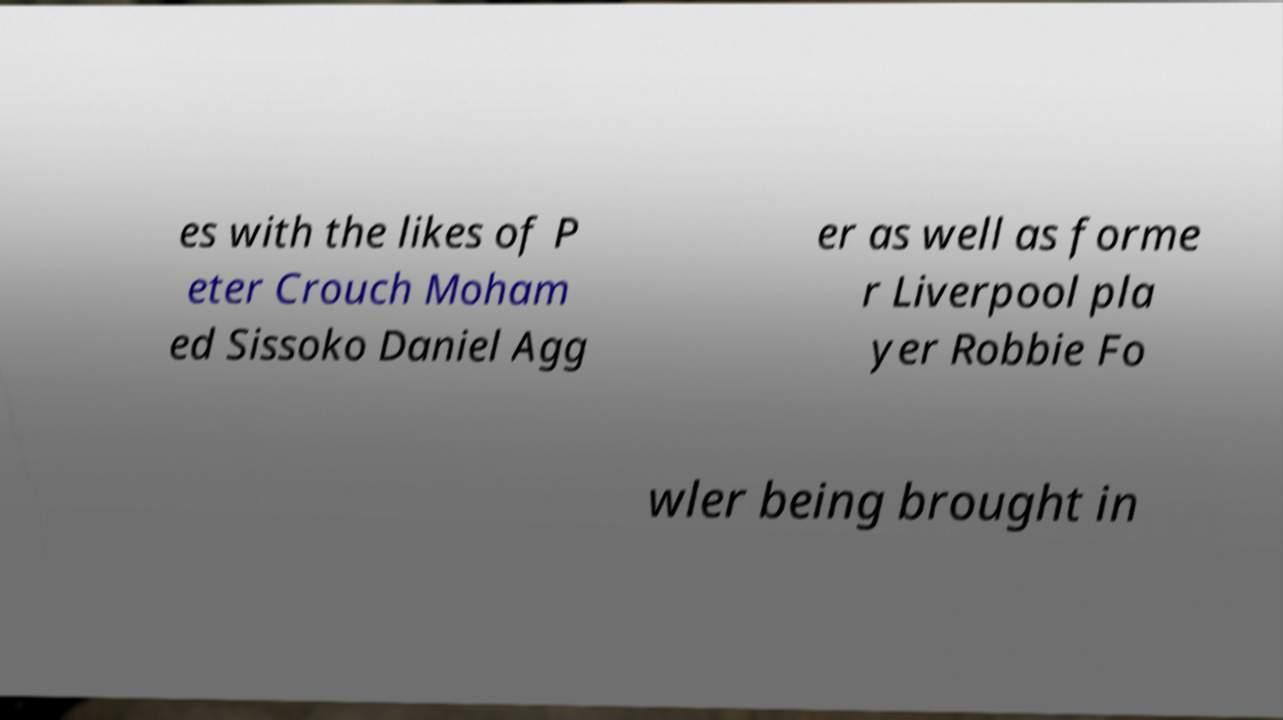For documentation purposes, I need the text within this image transcribed. Could you provide that? es with the likes of P eter Crouch Moham ed Sissoko Daniel Agg er as well as forme r Liverpool pla yer Robbie Fo wler being brought in 